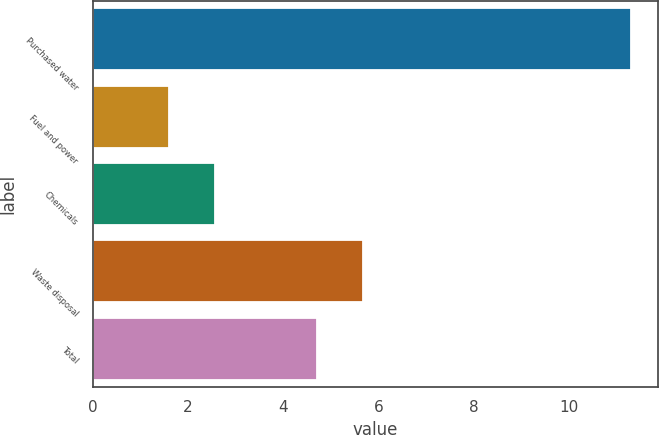Convert chart. <chart><loc_0><loc_0><loc_500><loc_500><bar_chart><fcel>Purchased water<fcel>Fuel and power<fcel>Chemicals<fcel>Waste disposal<fcel>Total<nl><fcel>11.3<fcel>1.6<fcel>2.57<fcel>5.67<fcel>4.7<nl></chart> 